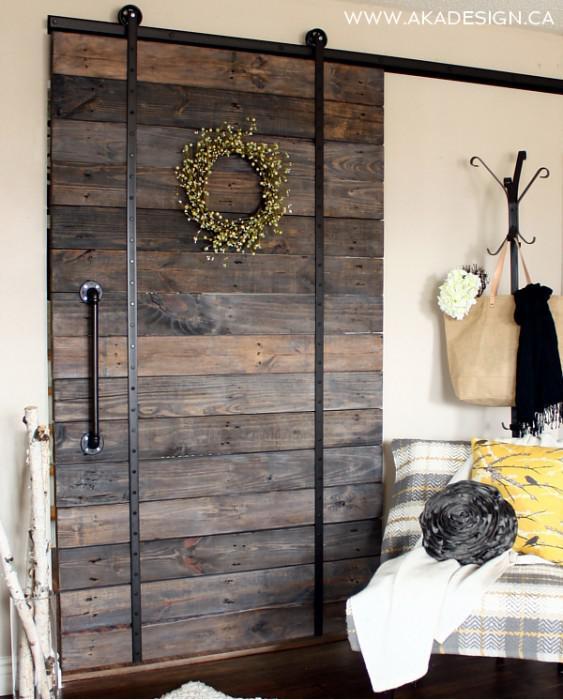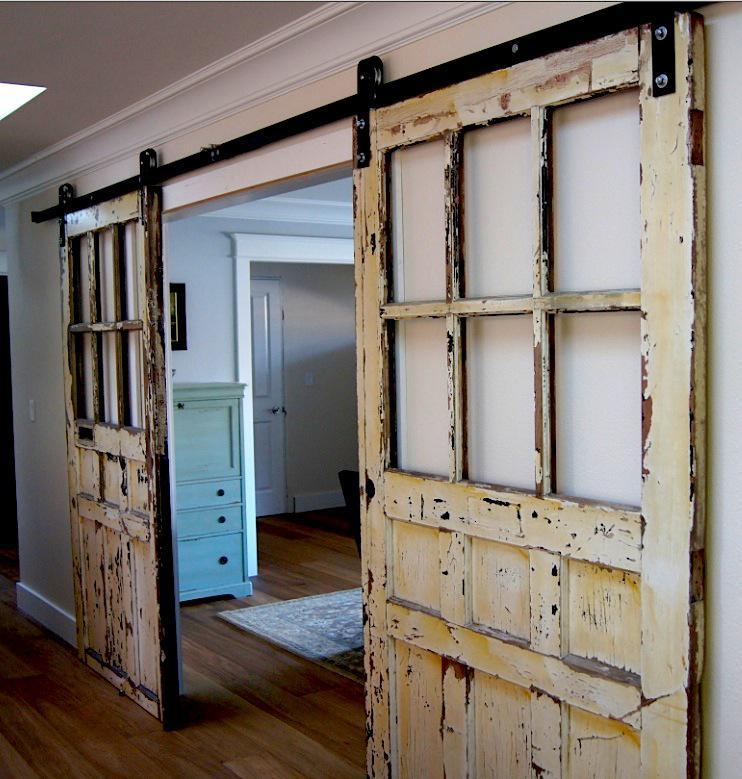The first image is the image on the left, the second image is the image on the right. Analyze the images presented: Is the assertion "One image shows a two-paneled barn door with angled wood trim and no windows." valid? Answer yes or no. No. 